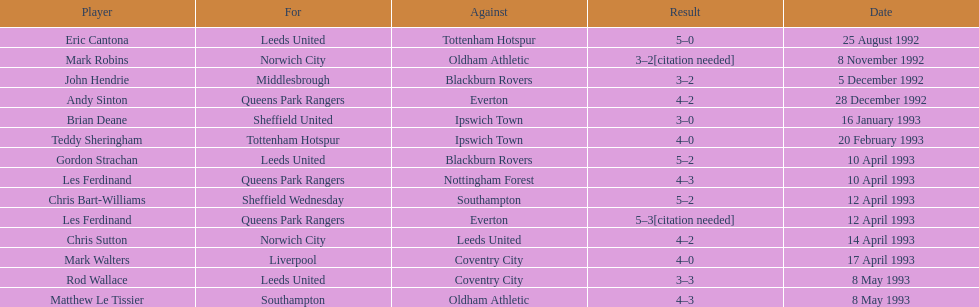Which team did liverpool play against? Coventry City. 